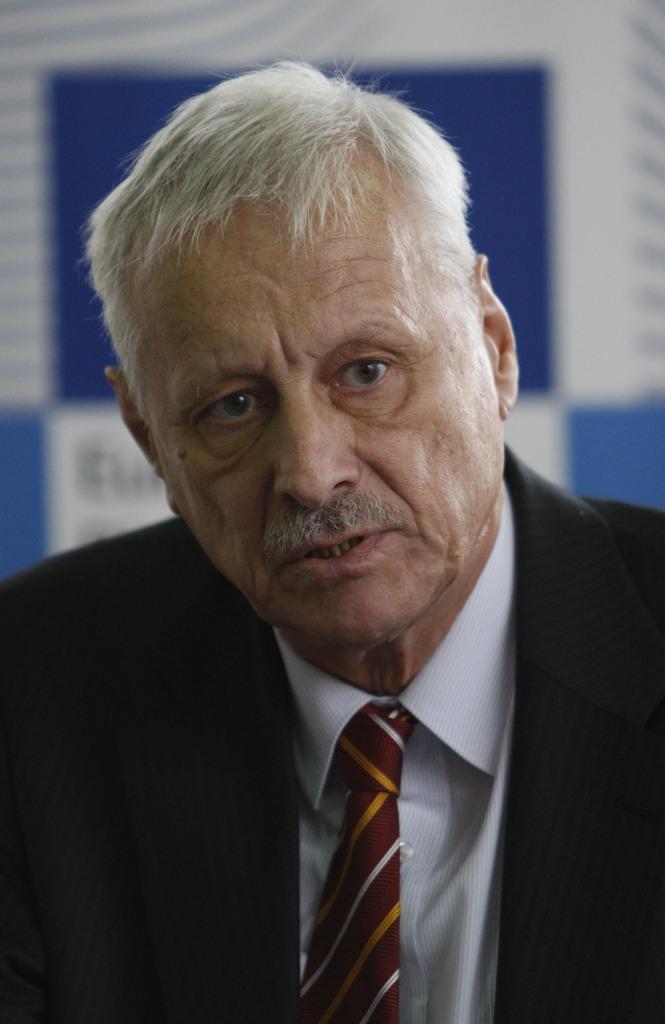Describe this image in one or two sentences. In this image I can see there is a man, he is wearing a blazer and there is a banner in the background. 